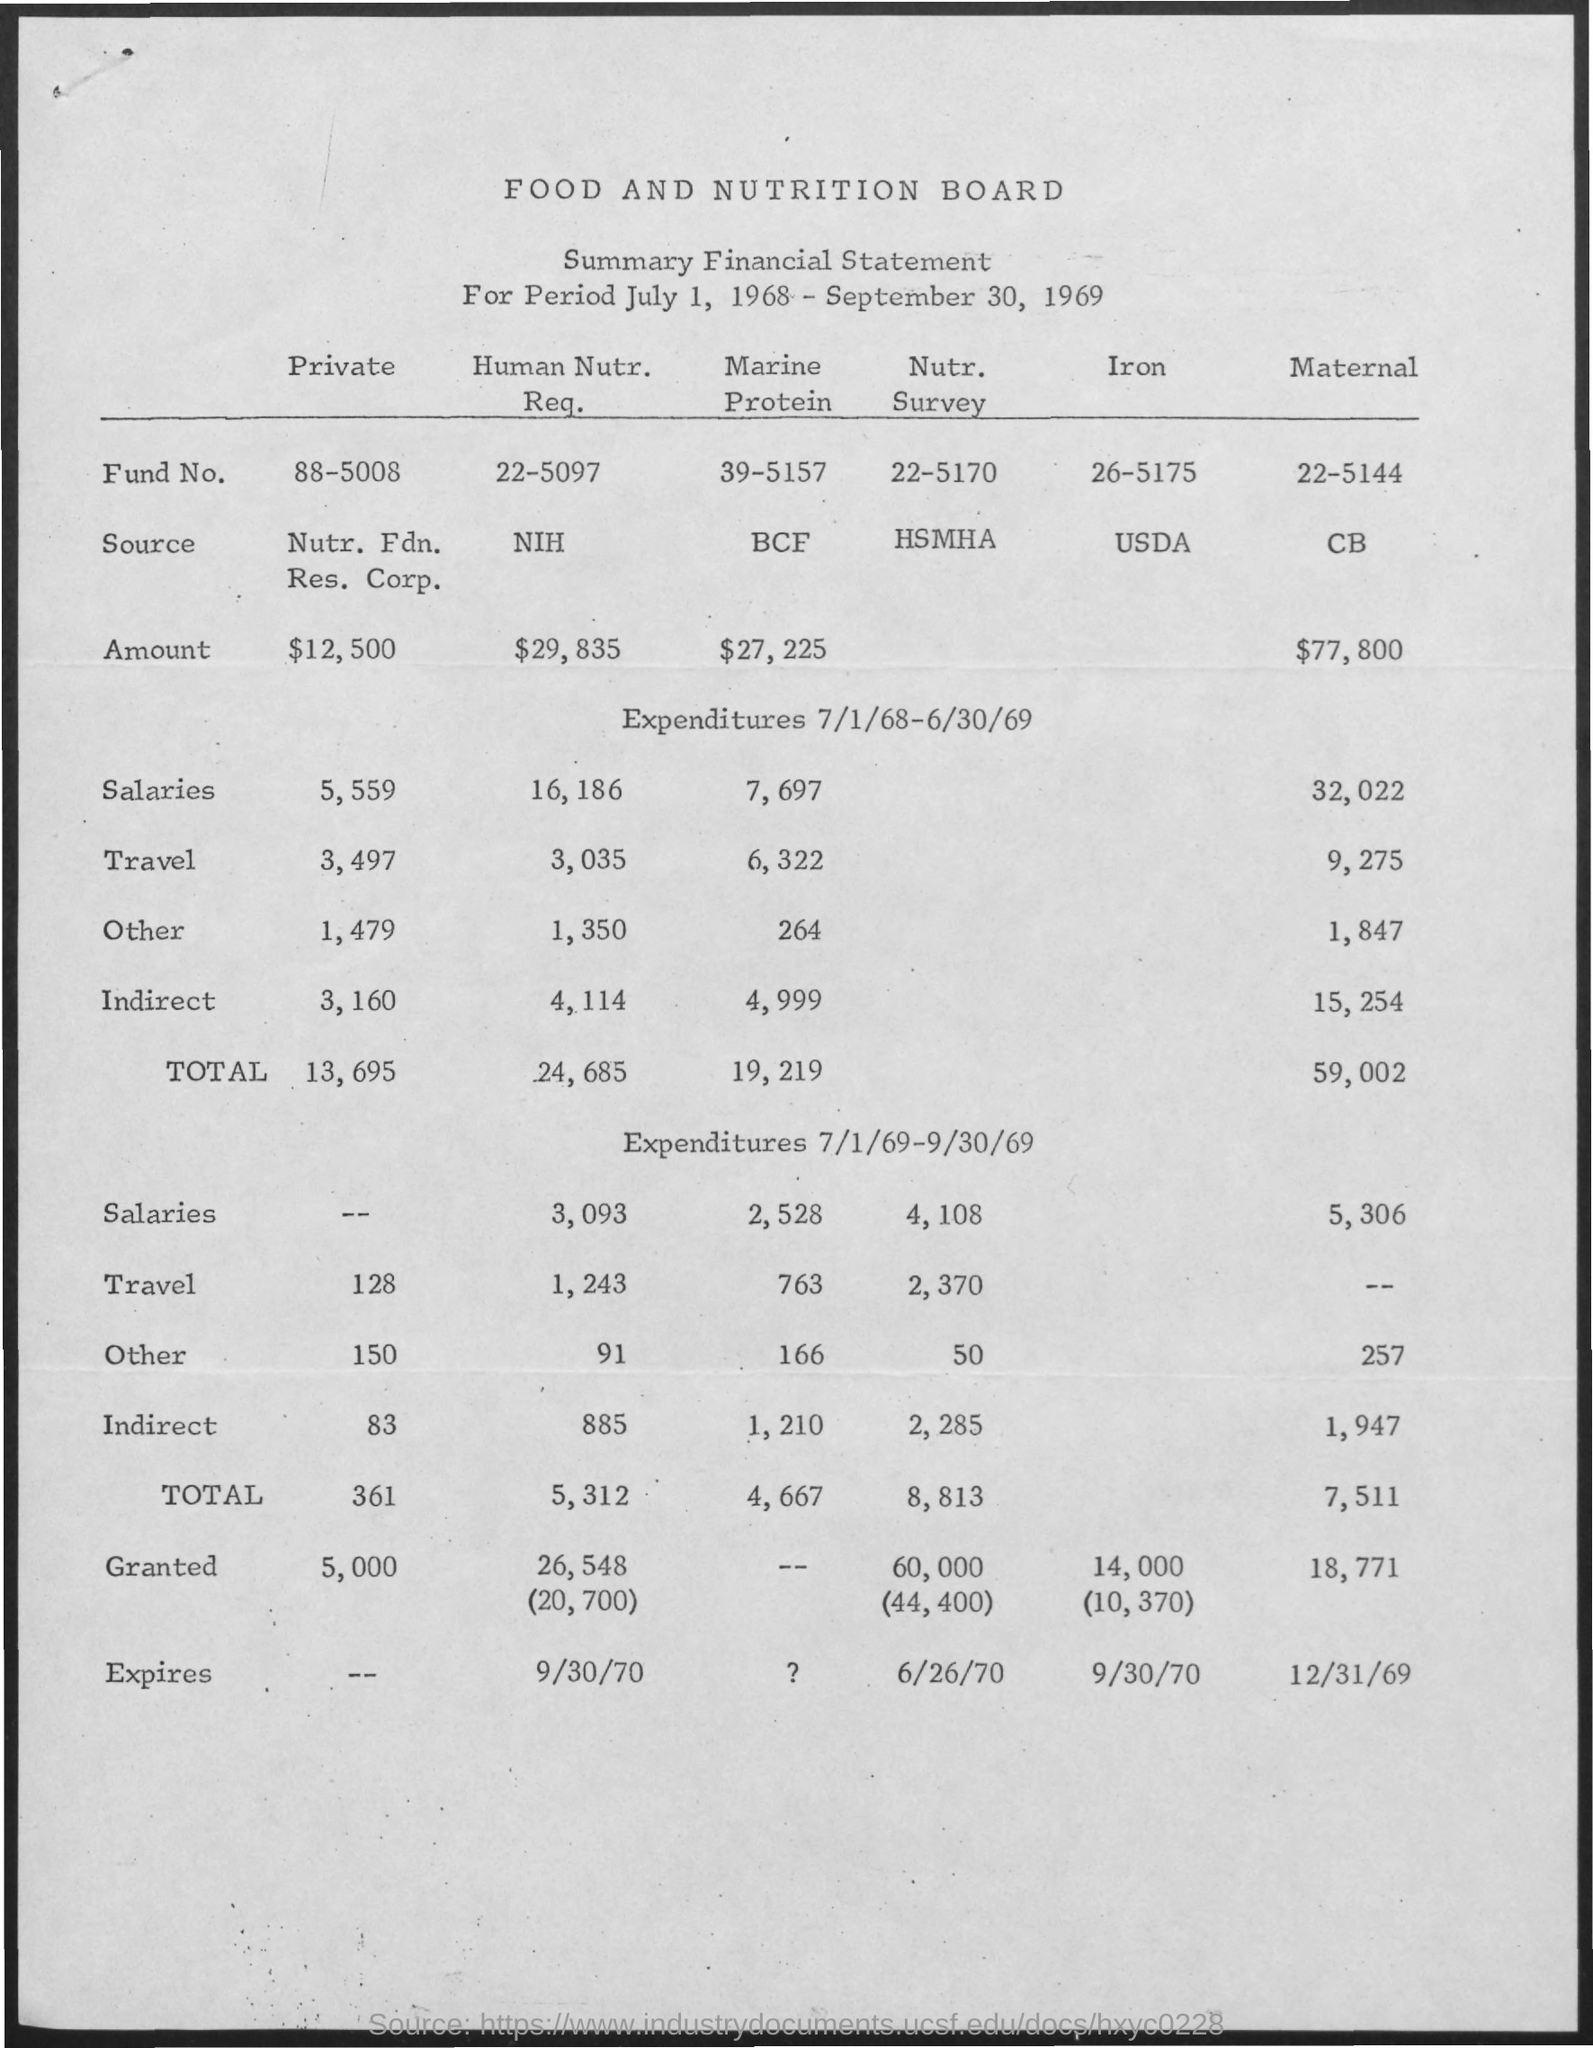Specify some key components in this picture. The Fund Number for the Nutrition Survey is 22-5170. The Fund Number for Iron is 26-5175. The title of the document is "Food and Nutrition Board. The amount for maternal care is $77,800. The amount for private is $12,500. 